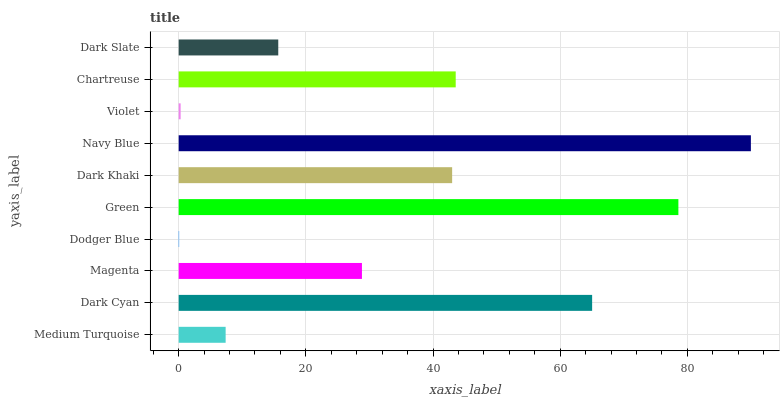Is Dodger Blue the minimum?
Answer yes or no. Yes. Is Navy Blue the maximum?
Answer yes or no. Yes. Is Dark Cyan the minimum?
Answer yes or no. No. Is Dark Cyan the maximum?
Answer yes or no. No. Is Dark Cyan greater than Medium Turquoise?
Answer yes or no. Yes. Is Medium Turquoise less than Dark Cyan?
Answer yes or no. Yes. Is Medium Turquoise greater than Dark Cyan?
Answer yes or no. No. Is Dark Cyan less than Medium Turquoise?
Answer yes or no. No. Is Dark Khaki the high median?
Answer yes or no. Yes. Is Magenta the low median?
Answer yes or no. Yes. Is Green the high median?
Answer yes or no. No. Is Violet the low median?
Answer yes or no. No. 